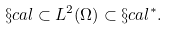Convert formula to latex. <formula><loc_0><loc_0><loc_500><loc_500>\S c a l \subset L ^ { 2 } ( \Omega ) \subset \S c a l ^ { * } .</formula> 